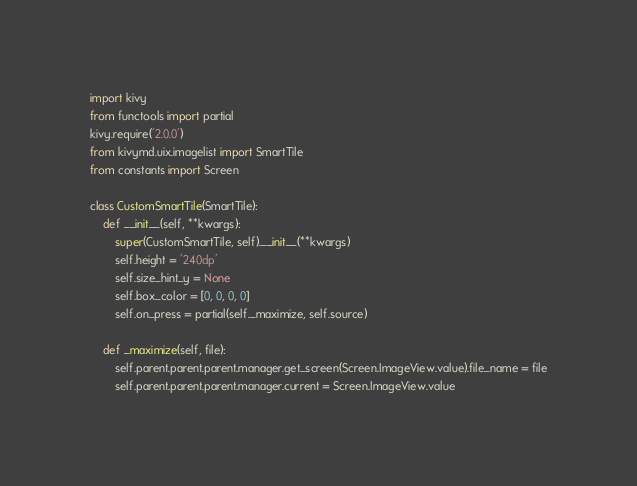Convert code to text. <code><loc_0><loc_0><loc_500><loc_500><_Python_>import kivy
from functools import partial
kivy.require('2.0.0')
from kivymd.uix.imagelist import SmartTile
from constants import Screen

class CustomSmartTile(SmartTile):
    def __init__(self, **kwargs):
        super(CustomSmartTile, self).__init__(**kwargs)
        self.height = '240dp'
        self.size_hint_y = None
        self.box_color = [0, 0, 0, 0]
        self.on_press = partial(self._maximize, self.source)

    def _maximize(self, file):
        self.parent.parent.parent.manager.get_screen(Screen.ImageView.value).file_name = file
        self.parent.parent.parent.manager.current = Screen.ImageView.value</code> 